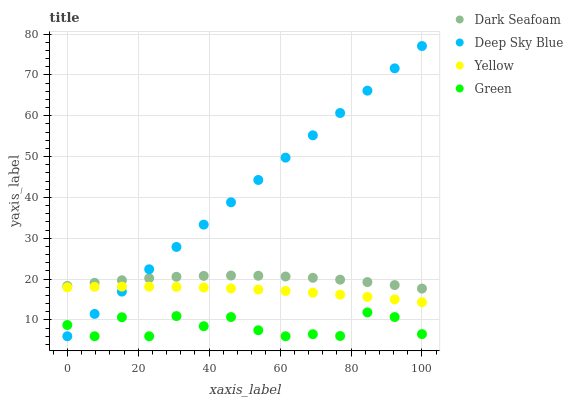Does Green have the minimum area under the curve?
Answer yes or no. Yes. Does Deep Sky Blue have the maximum area under the curve?
Answer yes or no. Yes. Does Yellow have the minimum area under the curve?
Answer yes or no. No. Does Yellow have the maximum area under the curve?
Answer yes or no. No. Is Deep Sky Blue the smoothest?
Answer yes or no. Yes. Is Green the roughest?
Answer yes or no. Yes. Is Yellow the smoothest?
Answer yes or no. No. Is Yellow the roughest?
Answer yes or no. No. Does Green have the lowest value?
Answer yes or no. Yes. Does Yellow have the lowest value?
Answer yes or no. No. Does Deep Sky Blue have the highest value?
Answer yes or no. Yes. Does Yellow have the highest value?
Answer yes or no. No. Is Green less than Dark Seafoam?
Answer yes or no. Yes. Is Dark Seafoam greater than Green?
Answer yes or no. Yes. Does Yellow intersect Deep Sky Blue?
Answer yes or no. Yes. Is Yellow less than Deep Sky Blue?
Answer yes or no. No. Is Yellow greater than Deep Sky Blue?
Answer yes or no. No. Does Green intersect Dark Seafoam?
Answer yes or no. No. 